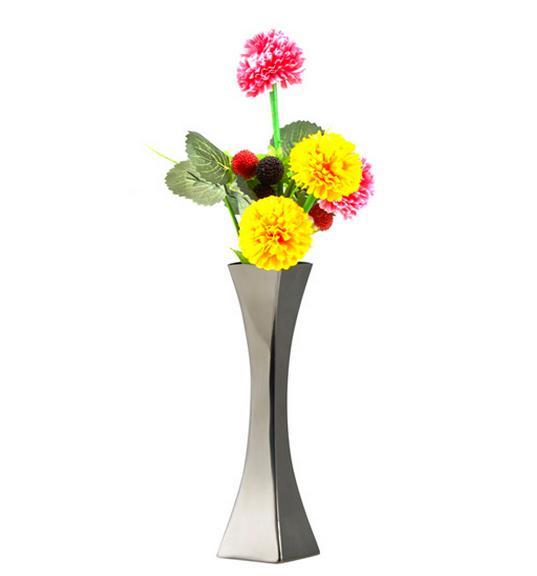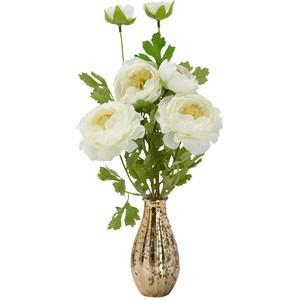The first image is the image on the left, the second image is the image on the right. Analyze the images presented: Is the assertion "The flowers in the clear glass vase are white with green stems." valid? Answer yes or no. No. 